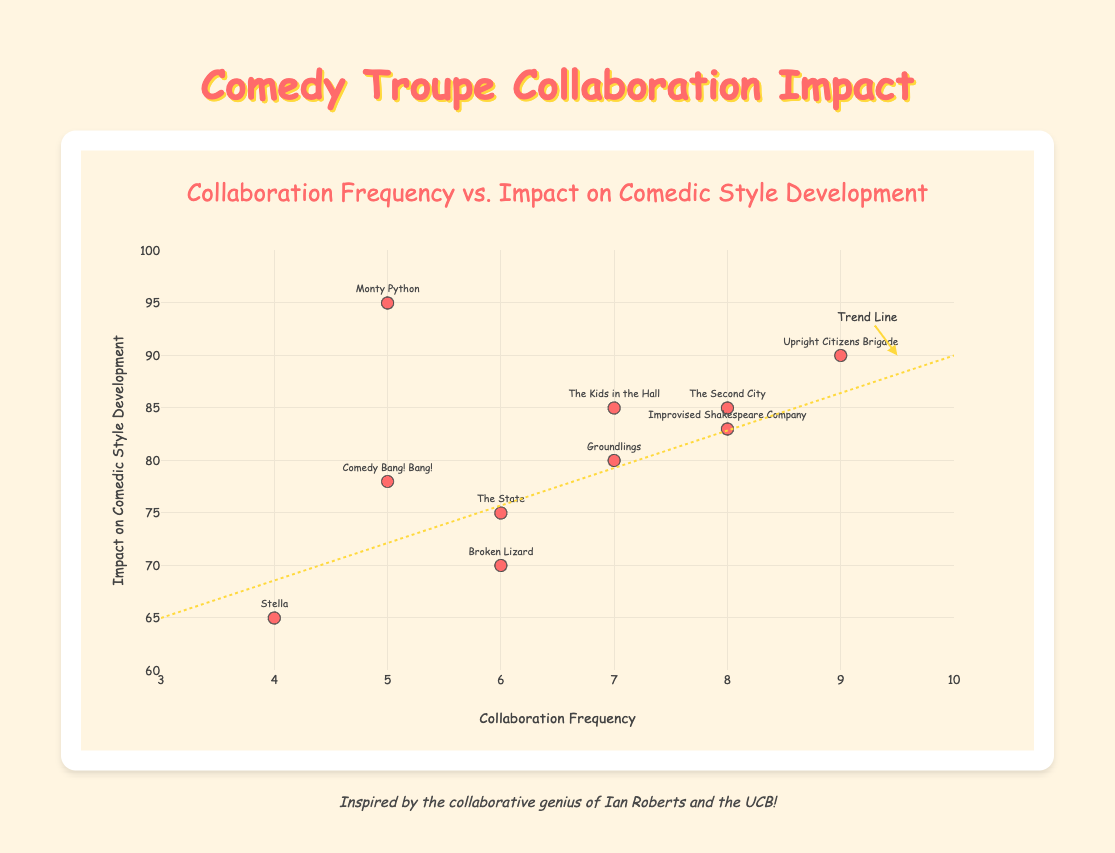What's the title of the scatter plot? The title is at the top of the chart and reads "Collaboration Frequency vs. Impact on Comedic Style Development".
Answer: Collaboration Frequency vs. Impact on Comedic Style Development How many comedy troupes are shown in the scatter plot? Count the number of different data points or labels in the scatter plot. Each point represents a comedy troupe.
Answer: 10 Which comedy troupe has the highest impact on comedic style development? Look for the highest point on the y-axis, which represents the impact on comedic style development. The corresponding troupe is Monty Python at 95.
Answer: Monty Python Which troupe has the highest collaboration frequency? Identify the point farthest to the right along the x-axis, which represents collaboration frequency. The Upright Citizens Brigade has the highest collaboration frequency at 9.
Answer: Upright Citizens Brigade What's the average impact on comedic style development across all troupes? Sum all the impact values and divide by the number of troupes: (85 + 90 + 80 + 75 + 95 + 85 + 70 + 65 + 78 + 83)/10 = 80.6.
Answer: 80.6 Which two troupes have the same impact on comedic style development but different collaboration frequencies? Identify points with the same y-values but different x-values. "The Second City" and "The Kids in the Hall" both have an impact of 85 but different collaboration frequencies (8 and 7, respectively).
Answer: The Second City and The Kids in the Hall What is the trend line's slope, and what does it indicate about collaboration frequency vs. impact on comedic style development? A trend line typically starts low and rises right, indicating a positive relationship. The slope shows that higher collaboration frequency generally correlates with higher impact on comedic style development. The slope visually looks to rise about 25 units of impact over 7 units of collaboration, giving a slope of approximately 3.57 (as estimated from the coordinate pivot points).
Answer: Indicates a positive correlation Which troupe is closest to the trend line but does not lie on it exactly? Look for points that are near but not on the trend line. "The State" (6, 75) seems close to the line but does not lie directly on it.
Answer: The State How does the trend line help in understanding the data? A trend line shows the general direction of the data points and helps identify the overall relationship. By looking at the slope and positioning, you can infer whether collaboration frequency generally leads to higher or lower impacts.
Answer: Shows positive correlation Are there any outliers, and which troupe represents the most significant deviation from the trend line? An outlier would be a data point that is far from the trend line compared to others. "Monty Python" (5, 95) stands out as it is high in impact but moderate in frequency, deviating significantly from the trend line.
Answer: Monty Python 